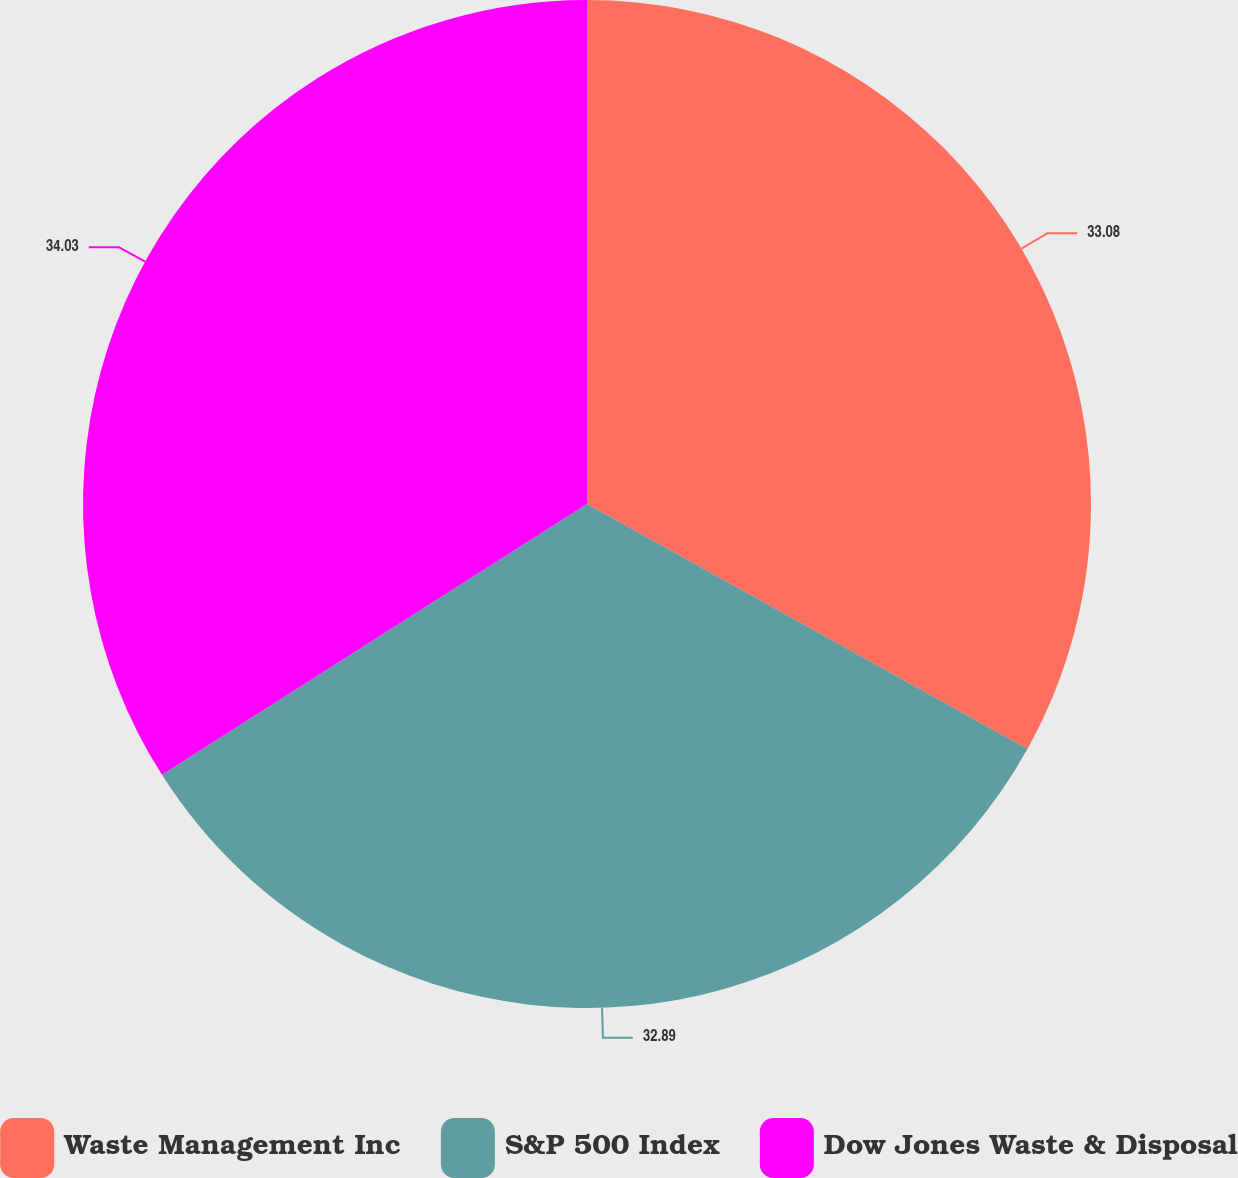Convert chart to OTSL. <chart><loc_0><loc_0><loc_500><loc_500><pie_chart><fcel>Waste Management Inc<fcel>S&P 500 Index<fcel>Dow Jones Waste & Disposal<nl><fcel>33.08%<fcel>32.89%<fcel>34.03%<nl></chart> 